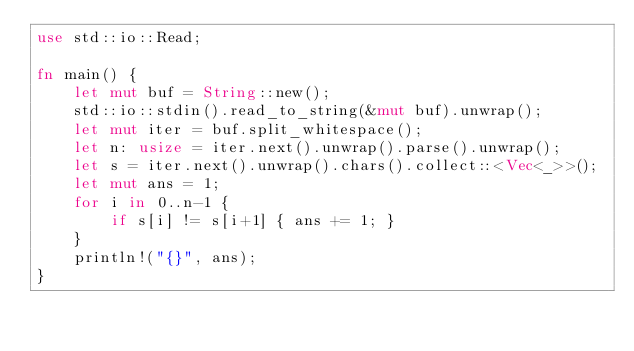<code> <loc_0><loc_0><loc_500><loc_500><_Rust_>use std::io::Read;

fn main() {
    let mut buf = String::new();
    std::io::stdin().read_to_string(&mut buf).unwrap();
    let mut iter = buf.split_whitespace();
    let n: usize = iter.next().unwrap().parse().unwrap();
    let s = iter.next().unwrap().chars().collect::<Vec<_>>();
    let mut ans = 1;
    for i in 0..n-1 {
        if s[i] != s[i+1] { ans += 1; }
    }
    println!("{}", ans);
}
</code> 